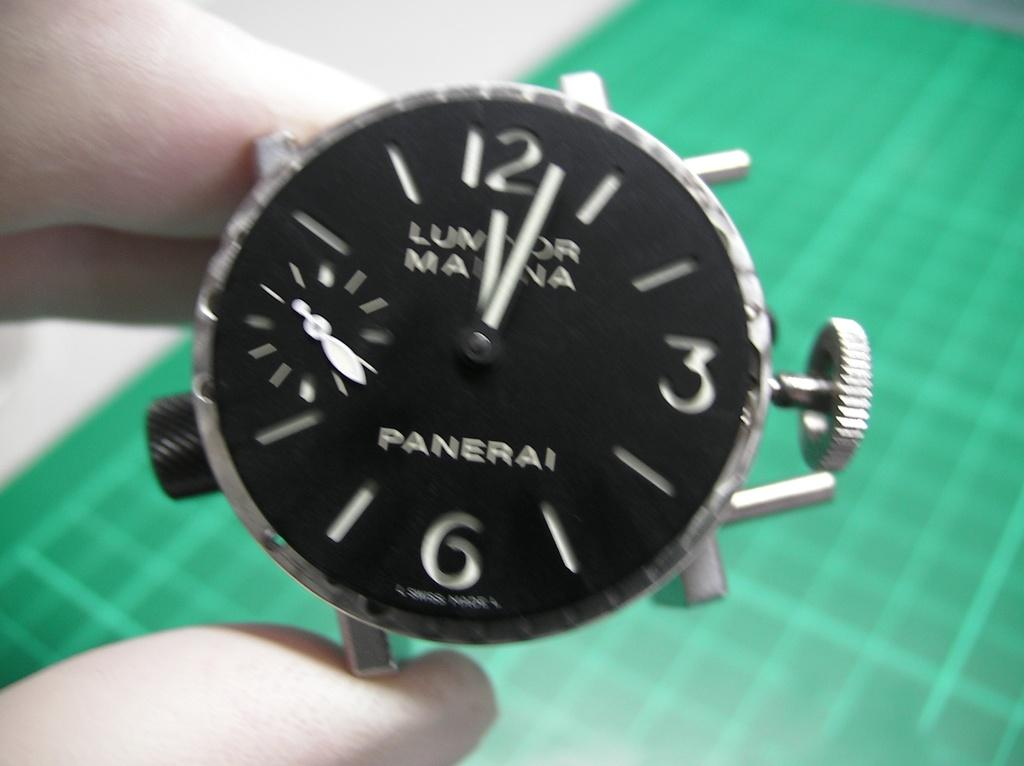<image>
Provide a brief description of the given image. A blurred close up of a black faced Panerai watch which reads a few minutes after 12. 